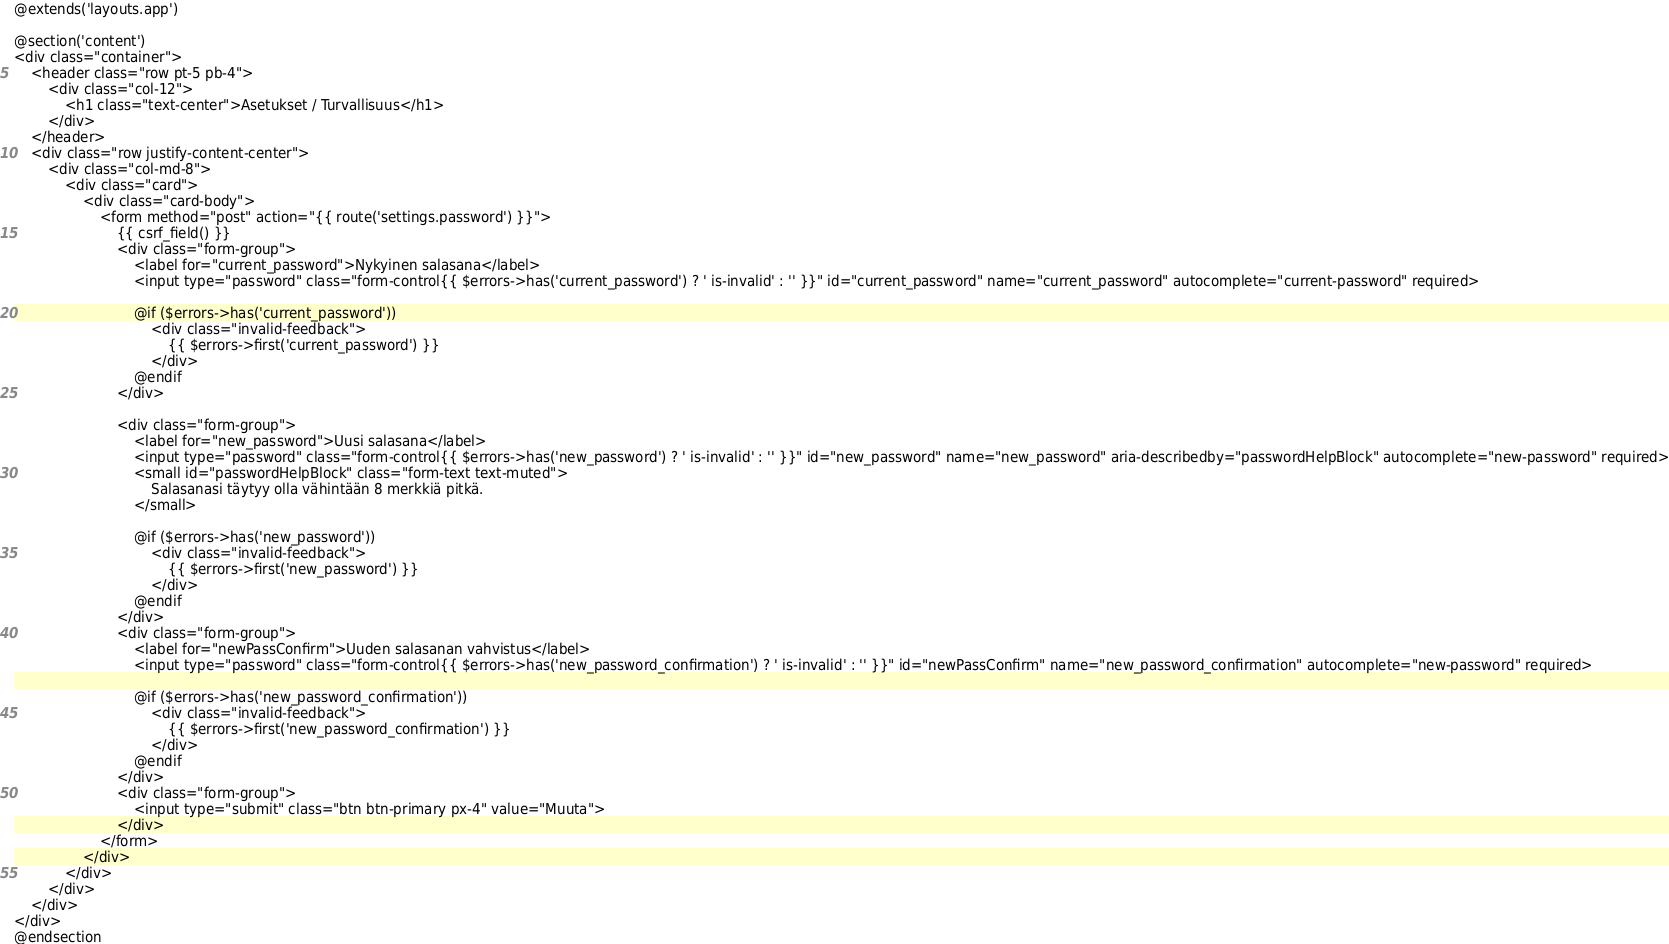Convert code to text. <code><loc_0><loc_0><loc_500><loc_500><_PHP_>@extends('layouts.app')

@section('content')
<div class="container">
    <header class="row pt-5 pb-4">
        <div class="col-12">
            <h1 class="text-center">Asetukset / Turvallisuus</h1>
        </div>
    </header>
    <div class="row justify-content-center">
        <div class="col-md-8">
            <div class="card">
                <div class="card-body">
                    <form method="post" action="{{ route('settings.password') }}">
                        {{ csrf_field() }}
                        <div class="form-group">
                            <label for="current_password">Nykyinen salasana</label>
                            <input type="password" class="form-control{{ $errors->has('current_password') ? ' is-invalid' : '' }}" id="current_password" name="current_password" autocomplete="current-password" required>

                            @if ($errors->has('current_password'))
                                <div class="invalid-feedback">
                                    {{ $errors->first('current_password') }}
                                </div>
                            @endif
                        </div>

                        <div class="form-group">
                            <label for="new_password">Uusi salasana</label>
                            <input type="password" class="form-control{{ $errors->has('new_password') ? ' is-invalid' : '' }}" id="new_password" name="new_password" aria-describedby="passwordHelpBlock" autocomplete="new-password" required>
                            <small id="passwordHelpBlock" class="form-text text-muted">
                                Salasanasi täytyy olla vähintään 8 merkkiä pitkä.
                            </small>

                            @if ($errors->has('new_password'))
                                <div class="invalid-feedback">
                                    {{ $errors->first('new_password') }}
                                </div>
                            @endif
                        </div>
                        <div class="form-group">
                            <label for="newPassConfirm">Uuden salasanan vahvistus</label>
                            <input type="password" class="form-control{{ $errors->has('new_password_confirmation') ? ' is-invalid' : '' }}" id="newPassConfirm" name="new_password_confirmation" autocomplete="new-password" required>

                            @if ($errors->has('new_password_confirmation'))
                                <div class="invalid-feedback">
                                    {{ $errors->first('new_password_confirmation') }}
                                </div>
                            @endif
                        </div>
                        <div class="form-group">
                            <input type="submit" class="btn btn-primary px-4" value="Muuta">
                        </div>
                    </form>
                </div>
            </div>
        </div>
    </div>
</div>
@endsection
</code> 